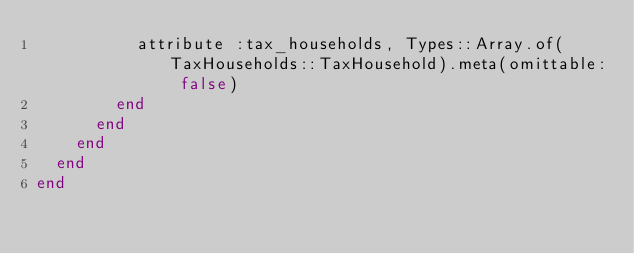<code> <loc_0><loc_0><loc_500><loc_500><_Ruby_>          attribute :tax_households, Types::Array.of(TaxHouseholds::TaxHousehold).meta(omittable: false)
        end
      end
    end
  end
end
</code> 